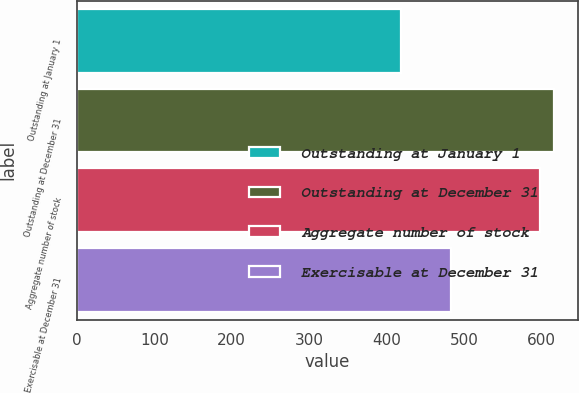Convert chart to OTSL. <chart><loc_0><loc_0><loc_500><loc_500><bar_chart><fcel>Outstanding at January 1<fcel>Outstanding at December 31<fcel>Aggregate number of stock<fcel>Exercisable at December 31<nl><fcel>419<fcel>616.7<fcel>598<fcel>483<nl></chart> 